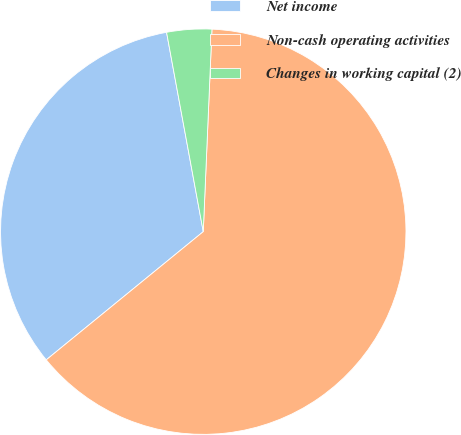Convert chart. <chart><loc_0><loc_0><loc_500><loc_500><pie_chart><fcel>Net income<fcel>Non-cash operating activities<fcel>Changes in working capital (2)<nl><fcel>33.0%<fcel>63.42%<fcel>3.58%<nl></chart> 